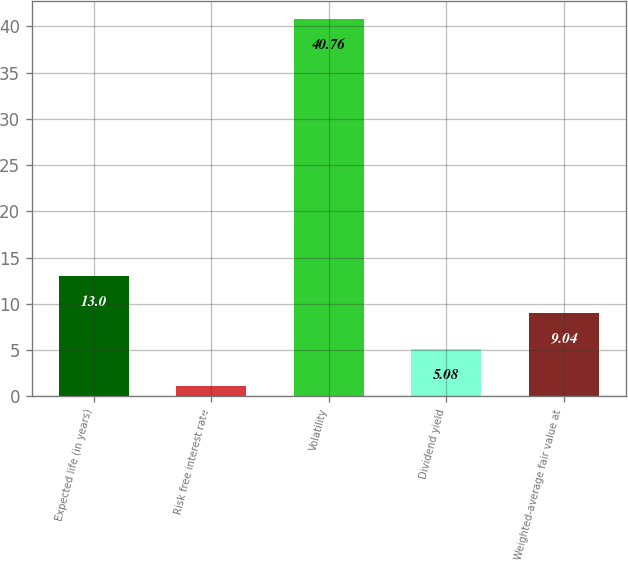Convert chart to OTSL. <chart><loc_0><loc_0><loc_500><loc_500><bar_chart><fcel>Expected life (in years)<fcel>Risk free interest rate<fcel>Volatility<fcel>Dividend yield<fcel>Weighted-average fair value at<nl><fcel>13<fcel>1.12<fcel>40.76<fcel>5.08<fcel>9.04<nl></chart> 